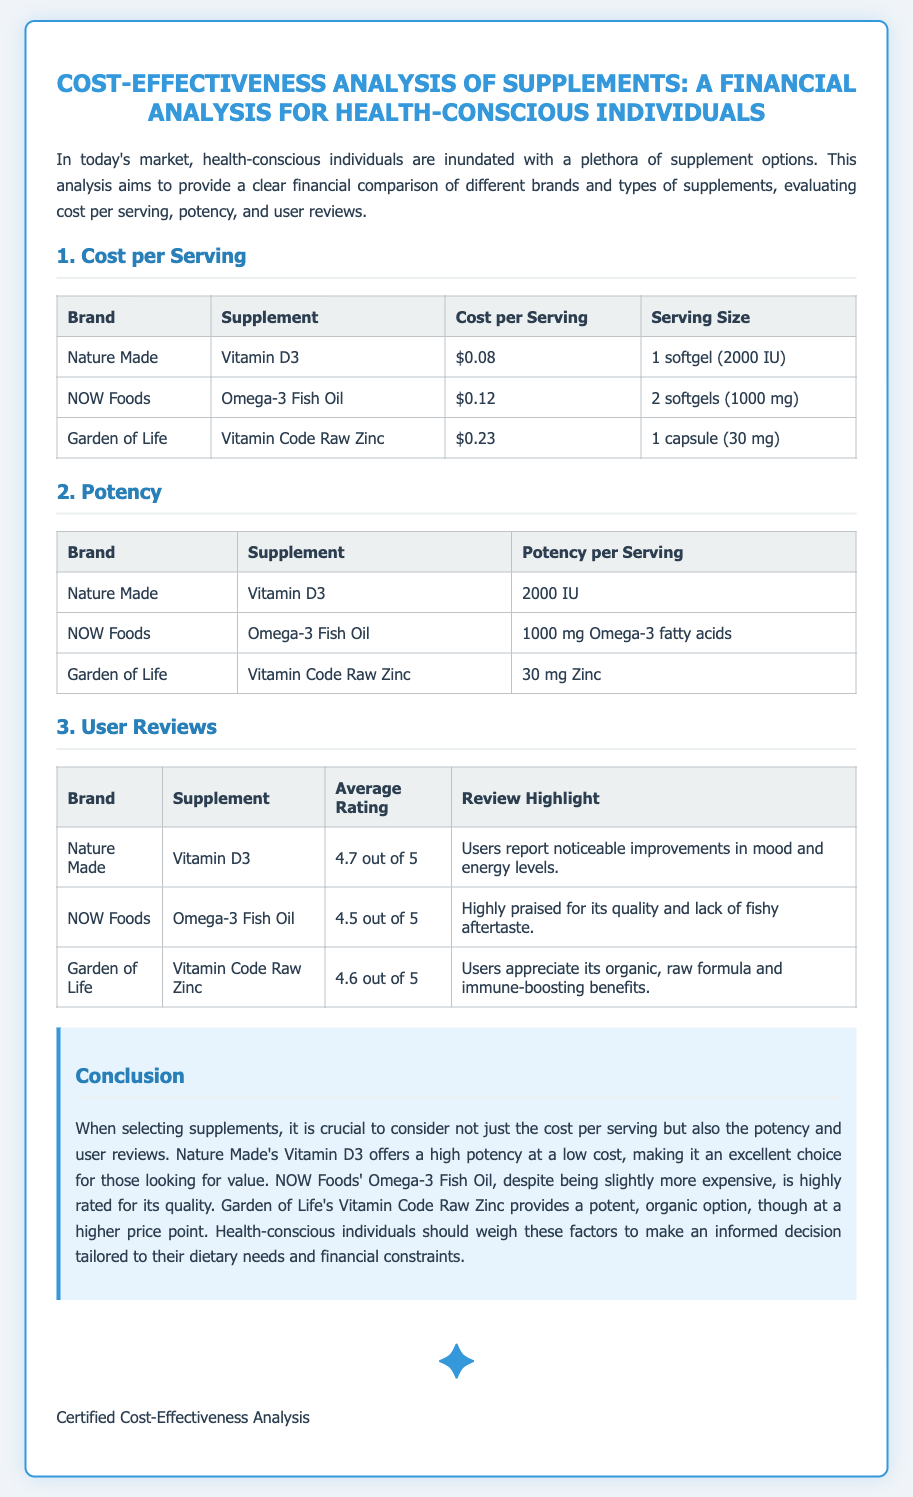what is the cost per serving of Nature Made Vitamin D3? The cost per serving is directly provided in the table under "Cost per Serving" for Nature Made Vitamin D3.
Answer: $0.08 what is the potency of NOW Foods Omega-3 Fish Oil? The potency per serving is given in the "Potency" table for NOW Foods Omega-3 Fish Oil.
Answer: 1000 mg Omega-3 fatty acids what is the average rating of Garden of Life Vitamin Code Raw Zinc? The average rating can be found in the "User Reviews" table for Garden of Life Vitamin Code Raw Zinc.
Answer: 4.6 out of 5 which supplement offers a high potency at a low cost? The conclusion section discusses the supplements and mentions which one offers high potency at a low cost.
Answer: Nature Made Vitamin D3 what review highlight is mentioned for NOW Foods Omega-3 Fish Oil? The review highlights section provides specific user comments for NOW Foods Omega-3 Fish Oil.
Answer: Highly praised for its quality and lack of fishy aftertaste which brand has a supplement that is organic and raw? The document specifies one brand in the context of providing an organic and raw formula.
Answer: Garden of Life what is the highest cost per serving listed in the document? The cost per serving table shows the costs, allowing for comparison to find the highest value.
Answer: $0.23 which supplement was noted for its immune-boosting benefits? The conclusion and reviews describe specific benefits of the supplements, highlighting any immune-boosting properties.
Answer: Vitamin Code Raw Zinc 